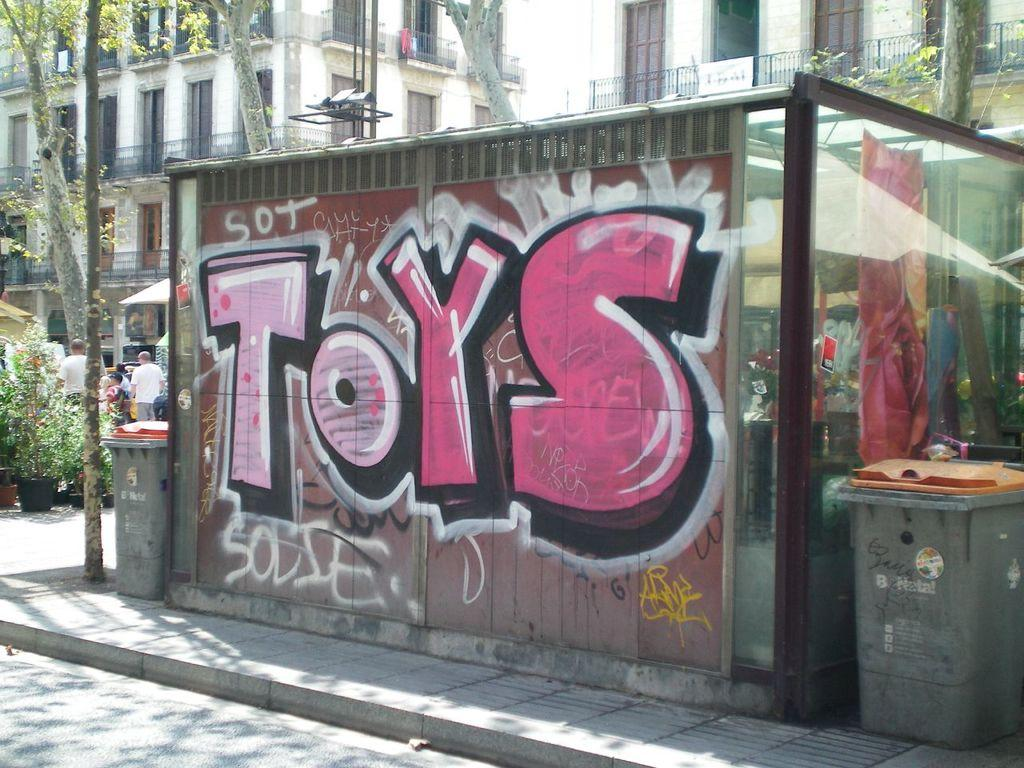<image>
Summarize the visual content of the image. The outside wall on a street with graffiti reading Toys 